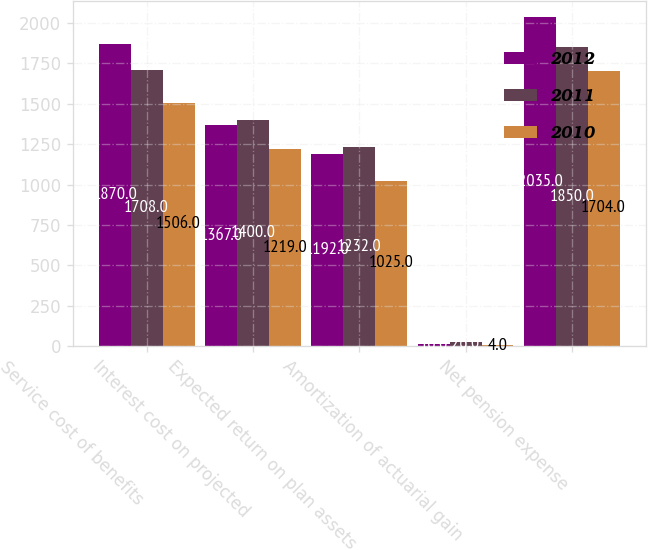<chart> <loc_0><loc_0><loc_500><loc_500><stacked_bar_chart><ecel><fcel>Service cost of benefits<fcel>Interest cost on projected<fcel>Expected return on plan assets<fcel>Amortization of actuarial gain<fcel>Net pension expense<nl><fcel>2012<fcel>1870<fcel>1367<fcel>1192<fcel>10<fcel>2035<nl><fcel>2011<fcel>1708<fcel>1400<fcel>1232<fcel>26<fcel>1850<nl><fcel>2010<fcel>1506<fcel>1219<fcel>1025<fcel>4<fcel>1704<nl></chart> 